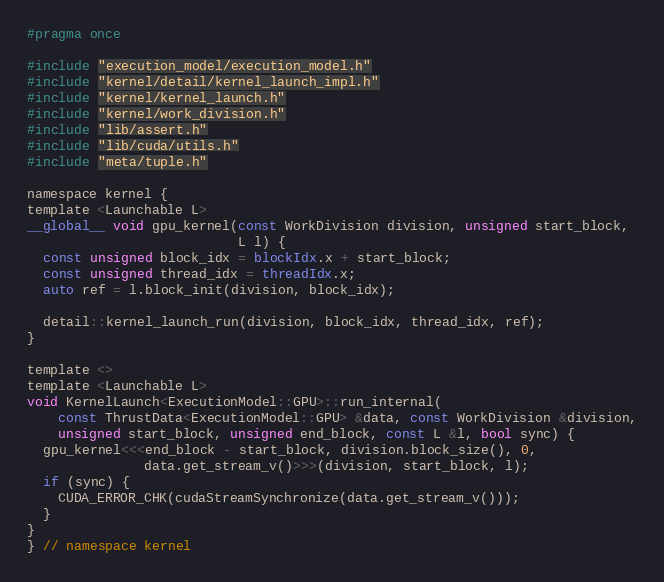Convert code to text. <code><loc_0><loc_0><loc_500><loc_500><_Cuda_>#pragma once

#include "execution_model/execution_model.h"
#include "kernel/detail/kernel_launch_impl.h"
#include "kernel/kernel_launch.h"
#include "kernel/work_division.h"
#include "lib/assert.h"
#include "lib/cuda/utils.h"
#include "meta/tuple.h"

namespace kernel {
template <Launchable L>
__global__ void gpu_kernel(const WorkDivision division, unsigned start_block,
                           L l) {
  const unsigned block_idx = blockIdx.x + start_block;
  const unsigned thread_idx = threadIdx.x;
  auto ref = l.block_init(division, block_idx);

  detail::kernel_launch_run(division, block_idx, thread_idx, ref);
}

template <>
template <Launchable L>
void KernelLaunch<ExecutionModel::GPU>::run_internal(
    const ThrustData<ExecutionModel::GPU> &data, const WorkDivision &division,
    unsigned start_block, unsigned end_block, const L &l, bool sync) {
  gpu_kernel<<<end_block - start_block, division.block_size(), 0,
               data.get_stream_v()>>>(division, start_block, l);
  if (sync) {
    CUDA_ERROR_CHK(cudaStreamSynchronize(data.get_stream_v()));
  }
}
} // namespace kernel
</code> 